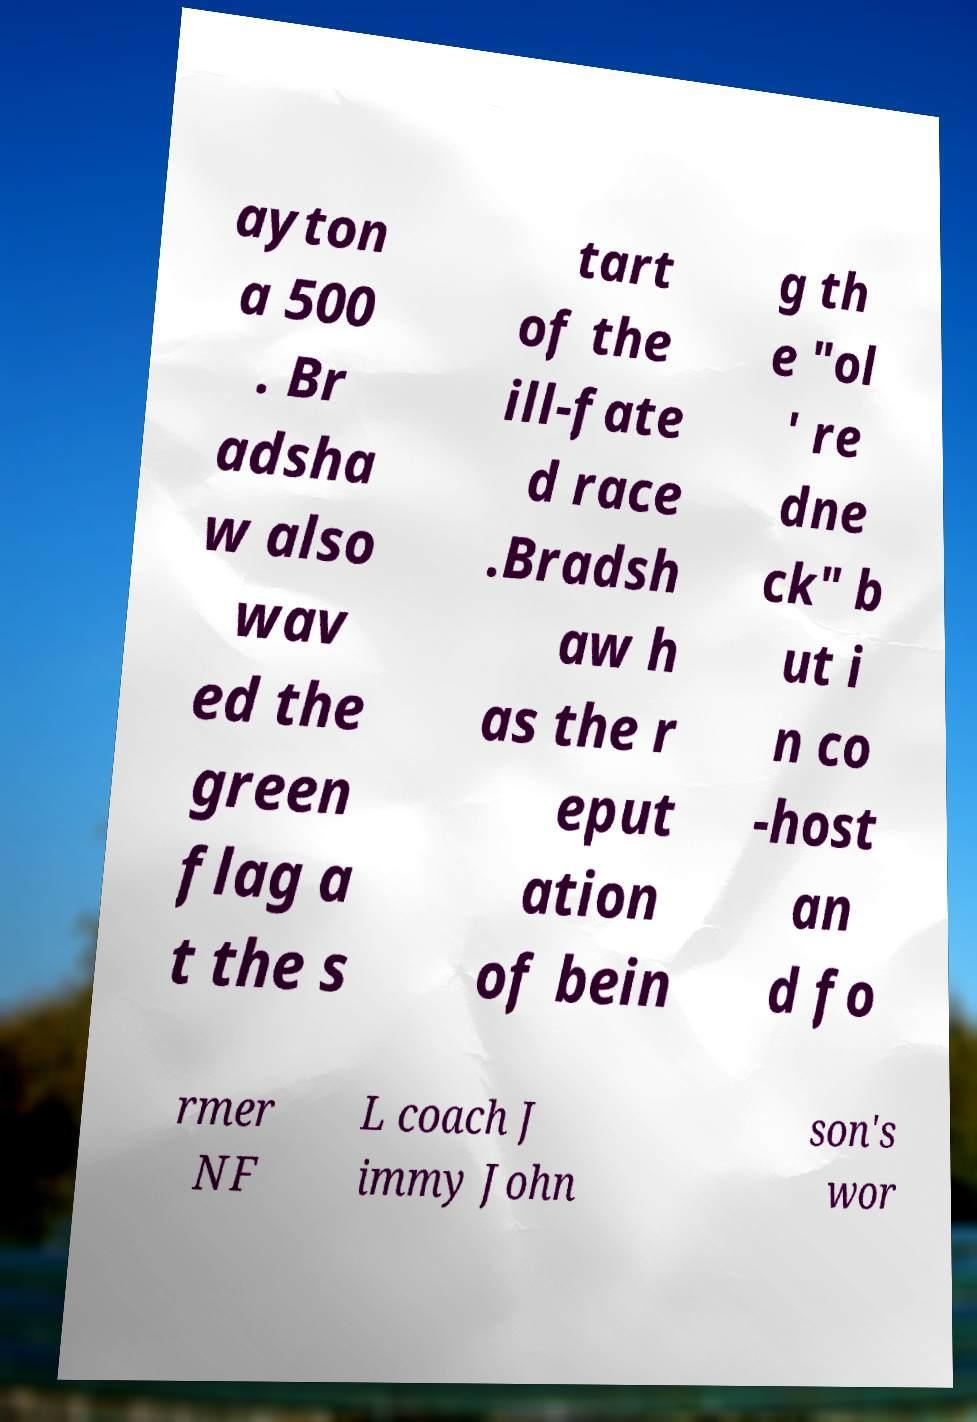I need the written content from this picture converted into text. Can you do that? ayton a 500 . Br adsha w also wav ed the green flag a t the s tart of the ill-fate d race .Bradsh aw h as the r eput ation of bein g th e "ol ' re dne ck" b ut i n co -host an d fo rmer NF L coach J immy John son's wor 